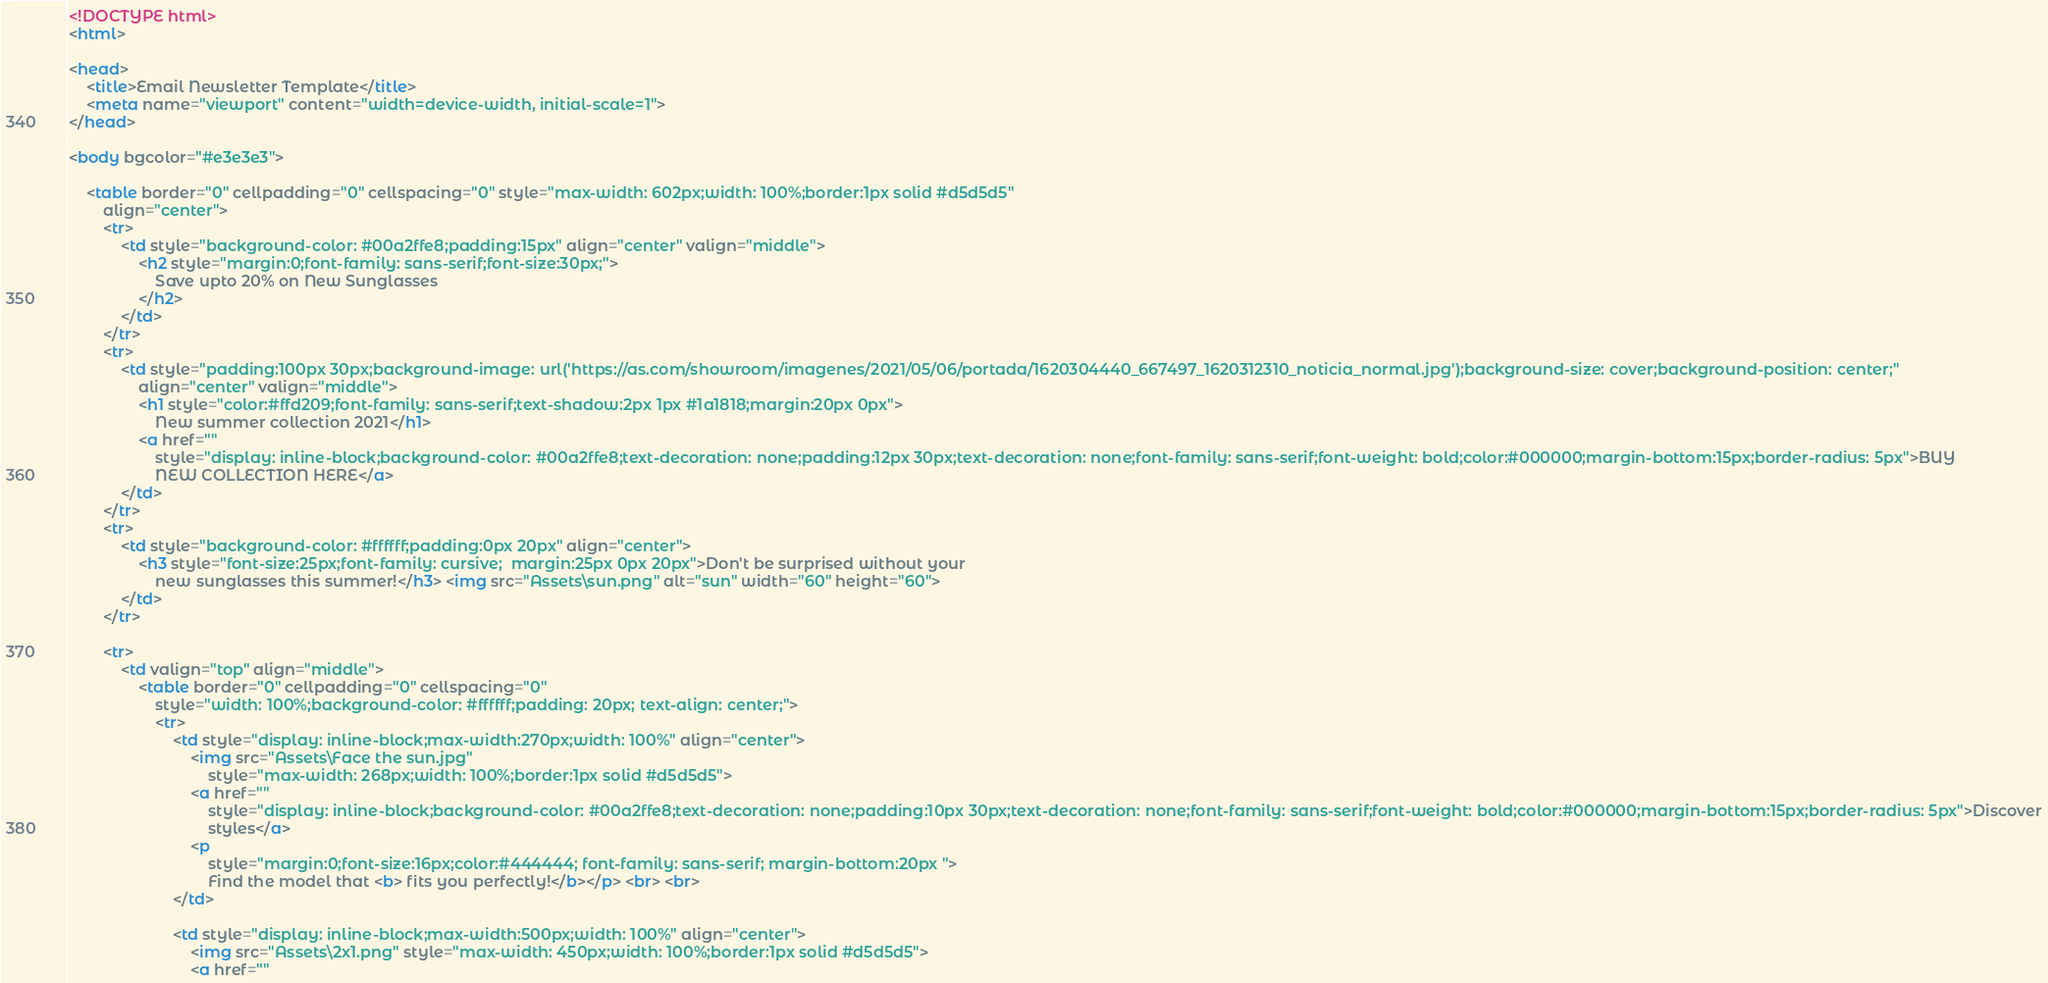<code> <loc_0><loc_0><loc_500><loc_500><_HTML_><!DOCTYPE html>
<html>

<head>
    <title>Email Newsletter Template</title>
    <meta name="viewport" content="width=device-width, initial-scale=1">
</head>

<body bgcolor="#e3e3e3">

    <table border="0" cellpadding="0" cellspacing="0" style="max-width: 602px;width: 100%;border:1px solid #d5d5d5"
        align="center">
        <tr>
            <td style="background-color: #00a2ffe8;padding:15px" align="center" valign="middle">
                <h2 style="margin:0;font-family: sans-serif;font-size:30px;">
                    Save upto 20% on New Sunglasses
                </h2>
            </td>
        </tr>
        <tr>
            <td style="padding:100px 30px;background-image: url('https://as.com/showroom/imagenes/2021/05/06/portada/1620304440_667497_1620312310_noticia_normal.jpg');background-size: cover;background-position: center;"
                align="center" valign="middle">
                <h1 style="color:#ffd209;font-family: sans-serif;text-shadow:2px 1px #1a1818;margin:20px 0px">
                    New summer collection 2021</h1>
                <a href=""
                    style="display: inline-block;background-color: #00a2ffe8;text-decoration: none;padding:12px 30px;text-decoration: none;font-family: sans-serif;font-weight: bold;color:#000000;margin-bottom:15px;border-radius: 5px">BUY
                    NEW COLLECTION HERE</a>
            </td>
        </tr>
        <tr>
            <td style="background-color: #ffffff;padding:0px 20px" align="center">
                <h3 style="font-size:25px;font-family: cursive;  margin:25px 0px 20px">Don't be surprised without your
                    new sunglasses this summer!</h3> <img src="Assets\sun.png" alt="sun" width="60" height="60">
            </td>
        </tr>

        <tr>
            <td valign="top" align="middle">
                <table border="0" cellpadding="0" cellspacing="0"
                    style="width: 100%;background-color: #ffffff;padding: 20px; text-align: center;">
                    <tr>
                        <td style="display: inline-block;max-width:270px;width: 100%" align="center">
                            <img src="Assets\Face the sun.jpg"
                                style="max-width: 268px;width: 100%;border:1px solid #d5d5d5">
                            <a href=""
                                style="display: inline-block;background-color: #00a2ffe8;text-decoration: none;padding:10px 30px;text-decoration: none;font-family: sans-serif;font-weight: bold;color:#000000;margin-bottom:15px;border-radius: 5px">Discover
                                styles</a>
                            <p
                                style="margin:0;font-size:16px;color:#444444; font-family: sans-serif; margin-bottom:20px ">
                                Find the model that <b> fits you perfectly!</b></p> <br> <br>
                        </td>

                        <td style="display: inline-block;max-width:500px;width: 100%" align="center">
                            <img src="Assets\2x1.png" style="max-width: 450px;width: 100%;border:1px solid #d5d5d5">
                            <a href=""</code> 